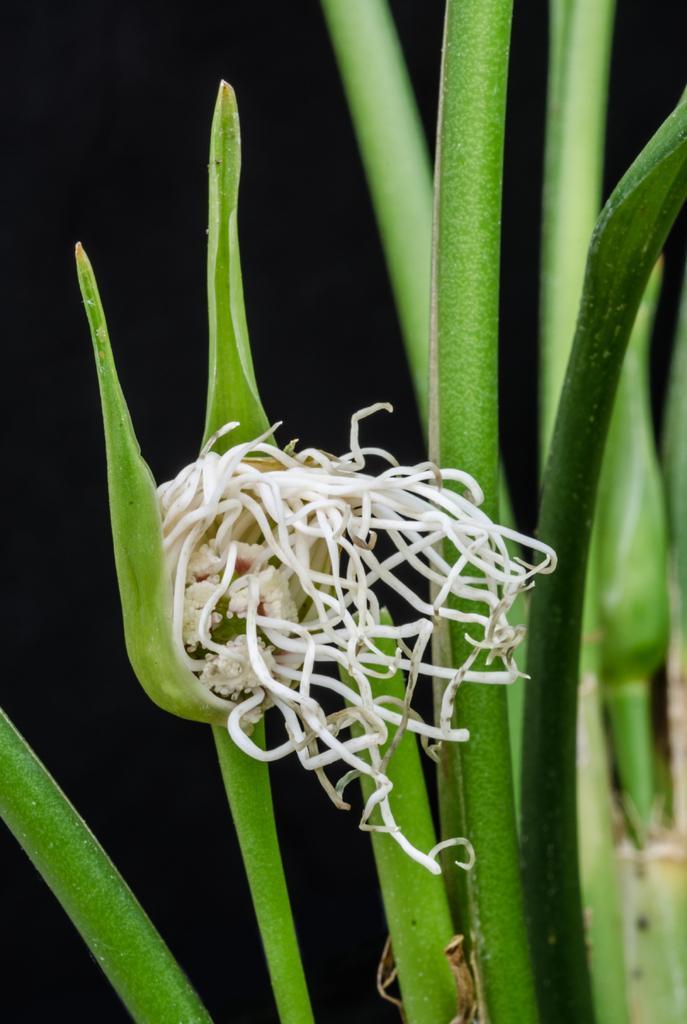How would you summarize this image in a sentence or two? In this image we can see a plant with a flower. 